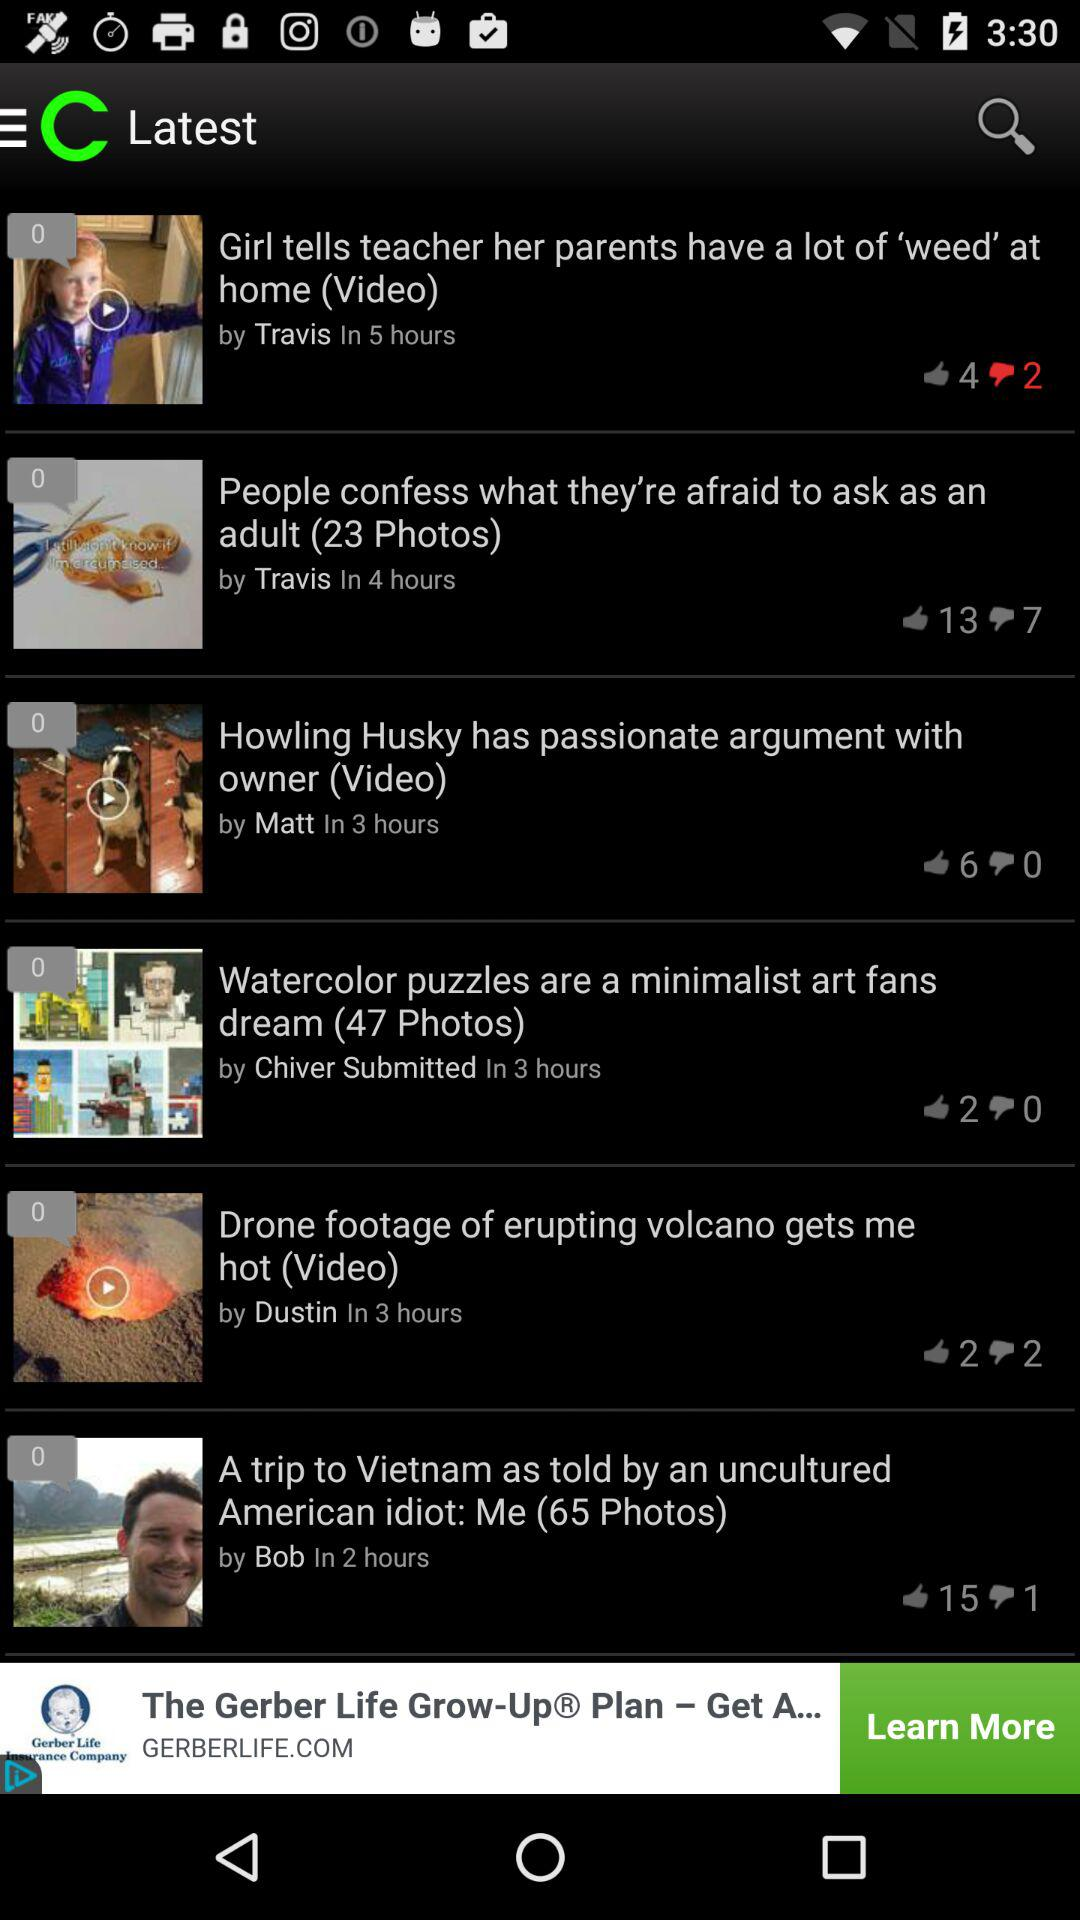How many comments did "Drone footage of erupting volcano gets me hot" get? "Drone footage of erupting volcano gets me hot" got 0 comments. 